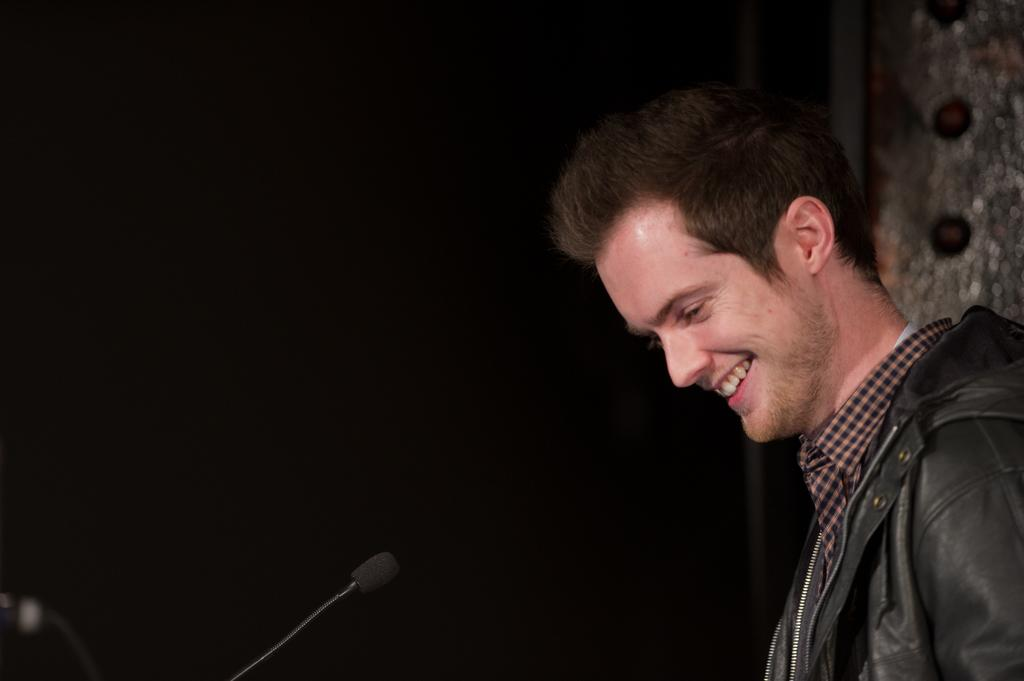Who is present in the image? There is a man in the image. What is the man wearing? The man is wearing a black jacket. What expression does the man have? The man is smiling. What can be seen on the left side of the image? There is a microphone on the left side of the image. How would you describe the background of the image? The background of the image is dark. What type of vase is visible in the scene? There is no vase present in the image; it features a man, a microphone, and a dark background. 